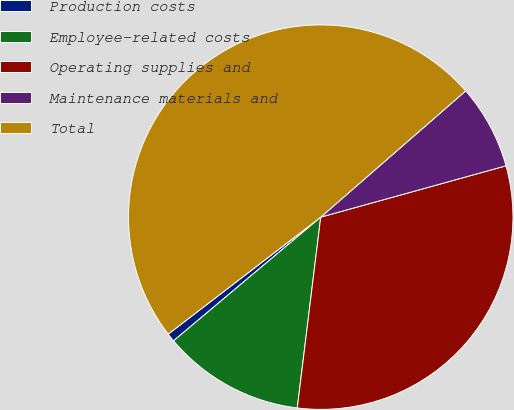<chart> <loc_0><loc_0><loc_500><loc_500><pie_chart><fcel>Production costs<fcel>Employee-related costs<fcel>Operating supplies and<fcel>Maintenance materials and<fcel>Total<nl><fcel>0.71%<fcel>11.93%<fcel>31.25%<fcel>7.1%<fcel>49.01%<nl></chart> 